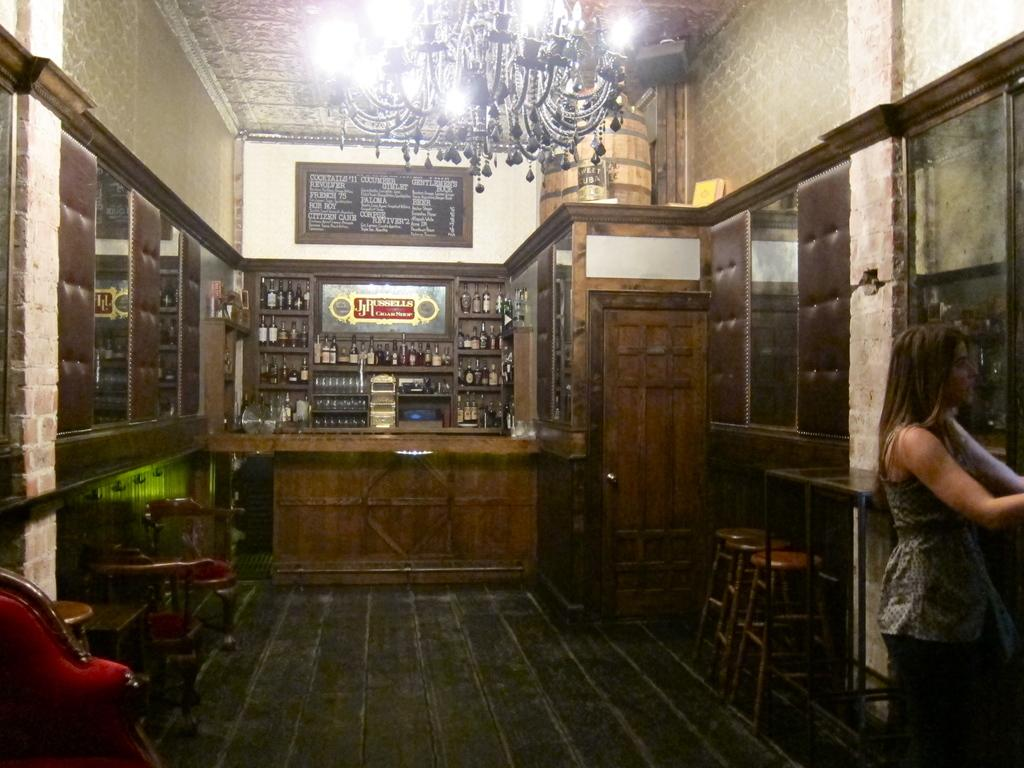Who is present in the image? There is a woman in the image. What piece of furniture is visible in the image? There is a chair in the image. What other piece of furniture is present in the image? There is a table in the image. What can be seen on the table in the background of the image? There are wine bottles on a table in the background of the image. What hobbies does the woman have, according to the image? The image does not provide information about the woman's hobbies. Is there a guide present in the image to help with wine selection? There is no guide present in the image; only wine bottles are visible on the table in the background. 